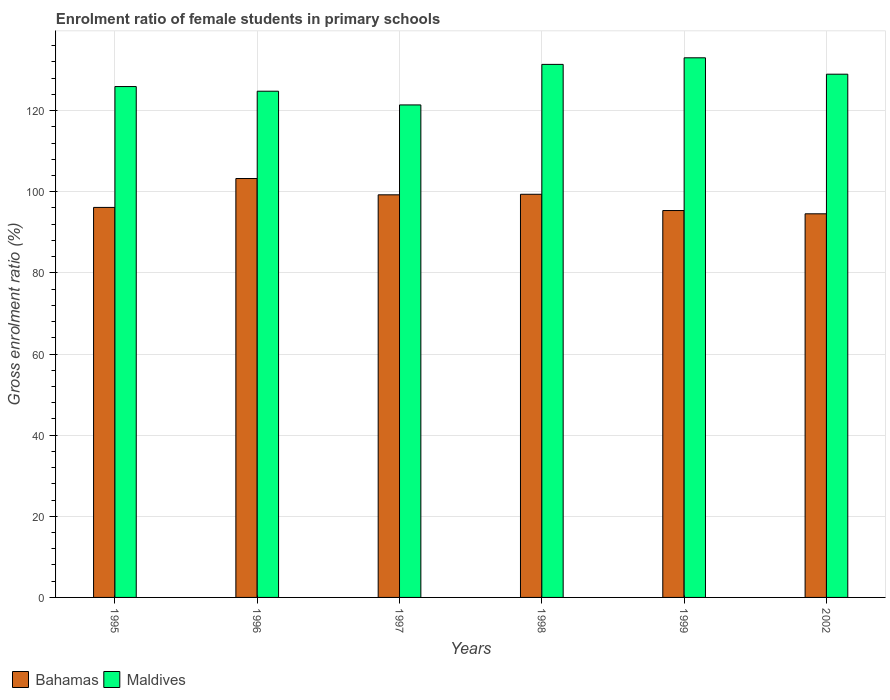How many different coloured bars are there?
Provide a short and direct response. 2. How many groups of bars are there?
Offer a terse response. 6. Are the number of bars per tick equal to the number of legend labels?
Provide a succinct answer. Yes. Are the number of bars on each tick of the X-axis equal?
Provide a succinct answer. Yes. How many bars are there on the 1st tick from the left?
Your response must be concise. 2. What is the label of the 1st group of bars from the left?
Your answer should be compact. 1995. In how many cases, is the number of bars for a given year not equal to the number of legend labels?
Give a very brief answer. 0. What is the enrolment ratio of female students in primary schools in Bahamas in 1995?
Offer a very short reply. 96.14. Across all years, what is the maximum enrolment ratio of female students in primary schools in Bahamas?
Offer a terse response. 103.26. Across all years, what is the minimum enrolment ratio of female students in primary schools in Bahamas?
Offer a terse response. 94.56. In which year was the enrolment ratio of female students in primary schools in Maldives maximum?
Your answer should be compact. 1999. What is the total enrolment ratio of female students in primary schools in Maldives in the graph?
Keep it short and to the point. 765.53. What is the difference between the enrolment ratio of female students in primary schools in Bahamas in 1995 and that in 1997?
Keep it short and to the point. -3.1. What is the difference between the enrolment ratio of female students in primary schools in Maldives in 1997 and the enrolment ratio of female students in primary schools in Bahamas in 1999?
Make the answer very short. 26.03. What is the average enrolment ratio of female students in primary schools in Bahamas per year?
Your response must be concise. 97.99. In the year 1995, what is the difference between the enrolment ratio of female students in primary schools in Maldives and enrolment ratio of female students in primary schools in Bahamas?
Provide a succinct answer. 29.79. In how many years, is the enrolment ratio of female students in primary schools in Maldives greater than 12 %?
Offer a very short reply. 6. What is the ratio of the enrolment ratio of female students in primary schools in Maldives in 1996 to that in 2002?
Give a very brief answer. 0.97. What is the difference between the highest and the second highest enrolment ratio of female students in primary schools in Maldives?
Provide a short and direct response. 1.62. What is the difference between the highest and the lowest enrolment ratio of female students in primary schools in Bahamas?
Provide a short and direct response. 8.7. In how many years, is the enrolment ratio of female students in primary schools in Maldives greater than the average enrolment ratio of female students in primary schools in Maldives taken over all years?
Your answer should be compact. 3. Is the sum of the enrolment ratio of female students in primary schools in Bahamas in 1999 and 2002 greater than the maximum enrolment ratio of female students in primary schools in Maldives across all years?
Offer a terse response. Yes. What does the 2nd bar from the left in 1997 represents?
Provide a short and direct response. Maldives. What does the 2nd bar from the right in 1999 represents?
Your answer should be compact. Bahamas. Are the values on the major ticks of Y-axis written in scientific E-notation?
Your response must be concise. No. Does the graph contain grids?
Give a very brief answer. Yes. How are the legend labels stacked?
Offer a very short reply. Horizontal. What is the title of the graph?
Keep it short and to the point. Enrolment ratio of female students in primary schools. Does "United States" appear as one of the legend labels in the graph?
Your response must be concise. No. What is the label or title of the X-axis?
Make the answer very short. Years. What is the Gross enrolment ratio (%) in Bahamas in 1995?
Ensure brevity in your answer.  96.14. What is the Gross enrolment ratio (%) of Maldives in 1995?
Keep it short and to the point. 125.93. What is the Gross enrolment ratio (%) in Bahamas in 1996?
Keep it short and to the point. 103.26. What is the Gross enrolment ratio (%) in Maldives in 1996?
Ensure brevity in your answer.  124.79. What is the Gross enrolment ratio (%) of Bahamas in 1997?
Ensure brevity in your answer.  99.25. What is the Gross enrolment ratio (%) of Maldives in 1997?
Provide a succinct answer. 121.41. What is the Gross enrolment ratio (%) in Bahamas in 1998?
Ensure brevity in your answer.  99.38. What is the Gross enrolment ratio (%) in Maldives in 1998?
Offer a terse response. 131.4. What is the Gross enrolment ratio (%) in Bahamas in 1999?
Keep it short and to the point. 95.37. What is the Gross enrolment ratio (%) of Maldives in 1999?
Ensure brevity in your answer.  133.02. What is the Gross enrolment ratio (%) in Bahamas in 2002?
Provide a succinct answer. 94.56. What is the Gross enrolment ratio (%) in Maldives in 2002?
Your response must be concise. 128.98. Across all years, what is the maximum Gross enrolment ratio (%) in Bahamas?
Your answer should be very brief. 103.26. Across all years, what is the maximum Gross enrolment ratio (%) in Maldives?
Offer a very short reply. 133.02. Across all years, what is the minimum Gross enrolment ratio (%) in Bahamas?
Provide a short and direct response. 94.56. Across all years, what is the minimum Gross enrolment ratio (%) of Maldives?
Give a very brief answer. 121.41. What is the total Gross enrolment ratio (%) in Bahamas in the graph?
Keep it short and to the point. 587.96. What is the total Gross enrolment ratio (%) in Maldives in the graph?
Keep it short and to the point. 765.53. What is the difference between the Gross enrolment ratio (%) of Bahamas in 1995 and that in 1996?
Your response must be concise. -7.12. What is the difference between the Gross enrolment ratio (%) of Maldives in 1995 and that in 1996?
Your answer should be compact. 1.15. What is the difference between the Gross enrolment ratio (%) in Bahamas in 1995 and that in 1997?
Offer a terse response. -3.1. What is the difference between the Gross enrolment ratio (%) of Maldives in 1995 and that in 1997?
Offer a very short reply. 4.53. What is the difference between the Gross enrolment ratio (%) in Bahamas in 1995 and that in 1998?
Your answer should be very brief. -3.24. What is the difference between the Gross enrolment ratio (%) of Maldives in 1995 and that in 1998?
Offer a terse response. -5.47. What is the difference between the Gross enrolment ratio (%) of Bahamas in 1995 and that in 1999?
Give a very brief answer. 0.77. What is the difference between the Gross enrolment ratio (%) in Maldives in 1995 and that in 1999?
Provide a succinct answer. -7.09. What is the difference between the Gross enrolment ratio (%) of Bahamas in 1995 and that in 2002?
Give a very brief answer. 1.58. What is the difference between the Gross enrolment ratio (%) of Maldives in 1995 and that in 2002?
Your answer should be compact. -3.05. What is the difference between the Gross enrolment ratio (%) of Bahamas in 1996 and that in 1997?
Keep it short and to the point. 4.02. What is the difference between the Gross enrolment ratio (%) in Maldives in 1996 and that in 1997?
Provide a short and direct response. 3.38. What is the difference between the Gross enrolment ratio (%) of Bahamas in 1996 and that in 1998?
Provide a succinct answer. 3.88. What is the difference between the Gross enrolment ratio (%) in Maldives in 1996 and that in 1998?
Make the answer very short. -6.61. What is the difference between the Gross enrolment ratio (%) in Bahamas in 1996 and that in 1999?
Provide a succinct answer. 7.89. What is the difference between the Gross enrolment ratio (%) in Maldives in 1996 and that in 1999?
Give a very brief answer. -8.24. What is the difference between the Gross enrolment ratio (%) of Bahamas in 1996 and that in 2002?
Ensure brevity in your answer.  8.7. What is the difference between the Gross enrolment ratio (%) in Maldives in 1996 and that in 2002?
Your response must be concise. -4.19. What is the difference between the Gross enrolment ratio (%) of Bahamas in 1997 and that in 1998?
Give a very brief answer. -0.13. What is the difference between the Gross enrolment ratio (%) of Maldives in 1997 and that in 1998?
Make the answer very short. -9.99. What is the difference between the Gross enrolment ratio (%) of Bahamas in 1997 and that in 1999?
Provide a succinct answer. 3.87. What is the difference between the Gross enrolment ratio (%) in Maldives in 1997 and that in 1999?
Offer a terse response. -11.62. What is the difference between the Gross enrolment ratio (%) in Bahamas in 1997 and that in 2002?
Your answer should be compact. 4.68. What is the difference between the Gross enrolment ratio (%) in Maldives in 1997 and that in 2002?
Your answer should be very brief. -7.57. What is the difference between the Gross enrolment ratio (%) in Bahamas in 1998 and that in 1999?
Keep it short and to the point. 4.01. What is the difference between the Gross enrolment ratio (%) of Maldives in 1998 and that in 1999?
Provide a short and direct response. -1.62. What is the difference between the Gross enrolment ratio (%) in Bahamas in 1998 and that in 2002?
Offer a very short reply. 4.81. What is the difference between the Gross enrolment ratio (%) in Maldives in 1998 and that in 2002?
Offer a terse response. 2.42. What is the difference between the Gross enrolment ratio (%) of Bahamas in 1999 and that in 2002?
Make the answer very short. 0.81. What is the difference between the Gross enrolment ratio (%) in Maldives in 1999 and that in 2002?
Offer a very short reply. 4.04. What is the difference between the Gross enrolment ratio (%) of Bahamas in 1995 and the Gross enrolment ratio (%) of Maldives in 1996?
Provide a short and direct response. -28.64. What is the difference between the Gross enrolment ratio (%) of Bahamas in 1995 and the Gross enrolment ratio (%) of Maldives in 1997?
Offer a very short reply. -25.26. What is the difference between the Gross enrolment ratio (%) in Bahamas in 1995 and the Gross enrolment ratio (%) in Maldives in 1998?
Your answer should be compact. -35.26. What is the difference between the Gross enrolment ratio (%) in Bahamas in 1995 and the Gross enrolment ratio (%) in Maldives in 1999?
Your answer should be very brief. -36.88. What is the difference between the Gross enrolment ratio (%) in Bahamas in 1995 and the Gross enrolment ratio (%) in Maldives in 2002?
Provide a short and direct response. -32.84. What is the difference between the Gross enrolment ratio (%) of Bahamas in 1996 and the Gross enrolment ratio (%) of Maldives in 1997?
Ensure brevity in your answer.  -18.14. What is the difference between the Gross enrolment ratio (%) of Bahamas in 1996 and the Gross enrolment ratio (%) of Maldives in 1998?
Your response must be concise. -28.14. What is the difference between the Gross enrolment ratio (%) in Bahamas in 1996 and the Gross enrolment ratio (%) in Maldives in 1999?
Provide a short and direct response. -29.76. What is the difference between the Gross enrolment ratio (%) in Bahamas in 1996 and the Gross enrolment ratio (%) in Maldives in 2002?
Provide a succinct answer. -25.72. What is the difference between the Gross enrolment ratio (%) of Bahamas in 1997 and the Gross enrolment ratio (%) of Maldives in 1998?
Make the answer very short. -32.16. What is the difference between the Gross enrolment ratio (%) in Bahamas in 1997 and the Gross enrolment ratio (%) in Maldives in 1999?
Provide a succinct answer. -33.78. What is the difference between the Gross enrolment ratio (%) of Bahamas in 1997 and the Gross enrolment ratio (%) of Maldives in 2002?
Provide a succinct answer. -29.73. What is the difference between the Gross enrolment ratio (%) in Bahamas in 1998 and the Gross enrolment ratio (%) in Maldives in 1999?
Provide a short and direct response. -33.64. What is the difference between the Gross enrolment ratio (%) of Bahamas in 1998 and the Gross enrolment ratio (%) of Maldives in 2002?
Give a very brief answer. -29.6. What is the difference between the Gross enrolment ratio (%) of Bahamas in 1999 and the Gross enrolment ratio (%) of Maldives in 2002?
Your answer should be compact. -33.61. What is the average Gross enrolment ratio (%) in Bahamas per year?
Give a very brief answer. 97.99. What is the average Gross enrolment ratio (%) of Maldives per year?
Offer a very short reply. 127.59. In the year 1995, what is the difference between the Gross enrolment ratio (%) in Bahamas and Gross enrolment ratio (%) in Maldives?
Keep it short and to the point. -29.79. In the year 1996, what is the difference between the Gross enrolment ratio (%) of Bahamas and Gross enrolment ratio (%) of Maldives?
Offer a terse response. -21.52. In the year 1997, what is the difference between the Gross enrolment ratio (%) in Bahamas and Gross enrolment ratio (%) in Maldives?
Keep it short and to the point. -22.16. In the year 1998, what is the difference between the Gross enrolment ratio (%) in Bahamas and Gross enrolment ratio (%) in Maldives?
Your response must be concise. -32.02. In the year 1999, what is the difference between the Gross enrolment ratio (%) in Bahamas and Gross enrolment ratio (%) in Maldives?
Provide a short and direct response. -37.65. In the year 2002, what is the difference between the Gross enrolment ratio (%) in Bahamas and Gross enrolment ratio (%) in Maldives?
Your answer should be compact. -34.42. What is the ratio of the Gross enrolment ratio (%) of Bahamas in 1995 to that in 1996?
Ensure brevity in your answer.  0.93. What is the ratio of the Gross enrolment ratio (%) in Maldives in 1995 to that in 1996?
Keep it short and to the point. 1.01. What is the ratio of the Gross enrolment ratio (%) of Bahamas in 1995 to that in 1997?
Provide a succinct answer. 0.97. What is the ratio of the Gross enrolment ratio (%) in Maldives in 1995 to that in 1997?
Your answer should be compact. 1.04. What is the ratio of the Gross enrolment ratio (%) in Bahamas in 1995 to that in 1998?
Keep it short and to the point. 0.97. What is the ratio of the Gross enrolment ratio (%) in Maldives in 1995 to that in 1998?
Provide a succinct answer. 0.96. What is the ratio of the Gross enrolment ratio (%) in Bahamas in 1995 to that in 1999?
Make the answer very short. 1.01. What is the ratio of the Gross enrolment ratio (%) in Maldives in 1995 to that in 1999?
Provide a short and direct response. 0.95. What is the ratio of the Gross enrolment ratio (%) in Bahamas in 1995 to that in 2002?
Provide a succinct answer. 1.02. What is the ratio of the Gross enrolment ratio (%) in Maldives in 1995 to that in 2002?
Provide a short and direct response. 0.98. What is the ratio of the Gross enrolment ratio (%) of Bahamas in 1996 to that in 1997?
Keep it short and to the point. 1.04. What is the ratio of the Gross enrolment ratio (%) in Maldives in 1996 to that in 1997?
Make the answer very short. 1.03. What is the ratio of the Gross enrolment ratio (%) in Bahamas in 1996 to that in 1998?
Your response must be concise. 1.04. What is the ratio of the Gross enrolment ratio (%) in Maldives in 1996 to that in 1998?
Make the answer very short. 0.95. What is the ratio of the Gross enrolment ratio (%) of Bahamas in 1996 to that in 1999?
Offer a terse response. 1.08. What is the ratio of the Gross enrolment ratio (%) of Maldives in 1996 to that in 1999?
Keep it short and to the point. 0.94. What is the ratio of the Gross enrolment ratio (%) in Bahamas in 1996 to that in 2002?
Offer a terse response. 1.09. What is the ratio of the Gross enrolment ratio (%) in Maldives in 1996 to that in 2002?
Provide a short and direct response. 0.97. What is the ratio of the Gross enrolment ratio (%) in Maldives in 1997 to that in 1998?
Offer a terse response. 0.92. What is the ratio of the Gross enrolment ratio (%) of Bahamas in 1997 to that in 1999?
Your answer should be very brief. 1.04. What is the ratio of the Gross enrolment ratio (%) of Maldives in 1997 to that in 1999?
Provide a succinct answer. 0.91. What is the ratio of the Gross enrolment ratio (%) of Bahamas in 1997 to that in 2002?
Provide a short and direct response. 1.05. What is the ratio of the Gross enrolment ratio (%) in Maldives in 1997 to that in 2002?
Your response must be concise. 0.94. What is the ratio of the Gross enrolment ratio (%) in Bahamas in 1998 to that in 1999?
Make the answer very short. 1.04. What is the ratio of the Gross enrolment ratio (%) in Maldives in 1998 to that in 1999?
Provide a succinct answer. 0.99. What is the ratio of the Gross enrolment ratio (%) in Bahamas in 1998 to that in 2002?
Keep it short and to the point. 1.05. What is the ratio of the Gross enrolment ratio (%) of Maldives in 1998 to that in 2002?
Make the answer very short. 1.02. What is the ratio of the Gross enrolment ratio (%) in Bahamas in 1999 to that in 2002?
Offer a terse response. 1.01. What is the ratio of the Gross enrolment ratio (%) of Maldives in 1999 to that in 2002?
Ensure brevity in your answer.  1.03. What is the difference between the highest and the second highest Gross enrolment ratio (%) in Bahamas?
Offer a very short reply. 3.88. What is the difference between the highest and the second highest Gross enrolment ratio (%) of Maldives?
Keep it short and to the point. 1.62. What is the difference between the highest and the lowest Gross enrolment ratio (%) in Bahamas?
Your answer should be compact. 8.7. What is the difference between the highest and the lowest Gross enrolment ratio (%) in Maldives?
Ensure brevity in your answer.  11.62. 